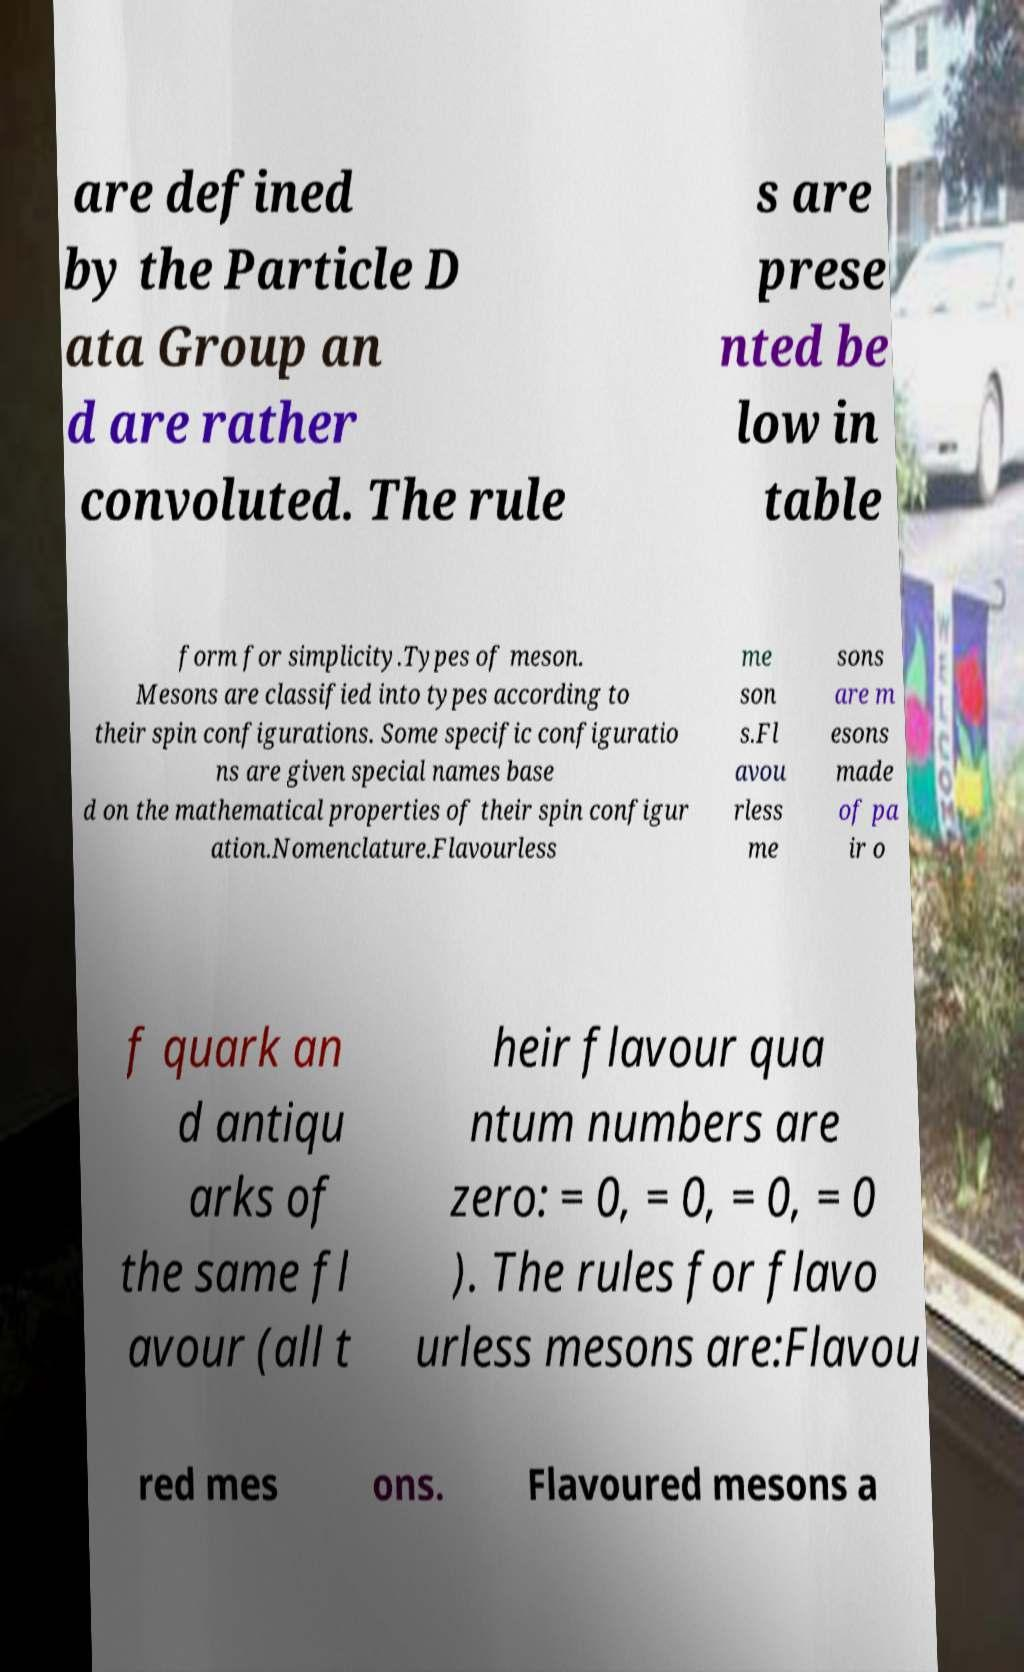Could you assist in decoding the text presented in this image and type it out clearly? are defined by the Particle D ata Group an d are rather convoluted. The rule s are prese nted be low in table form for simplicity.Types of meson. Mesons are classified into types according to their spin configurations. Some specific configuratio ns are given special names base d on the mathematical properties of their spin configur ation.Nomenclature.Flavourless me son s.Fl avou rless me sons are m esons made of pa ir o f quark an d antiqu arks of the same fl avour (all t heir flavour qua ntum numbers are zero: = 0, = 0, = 0, = 0 ). The rules for flavo urless mesons are:Flavou red mes ons. Flavoured mesons a 